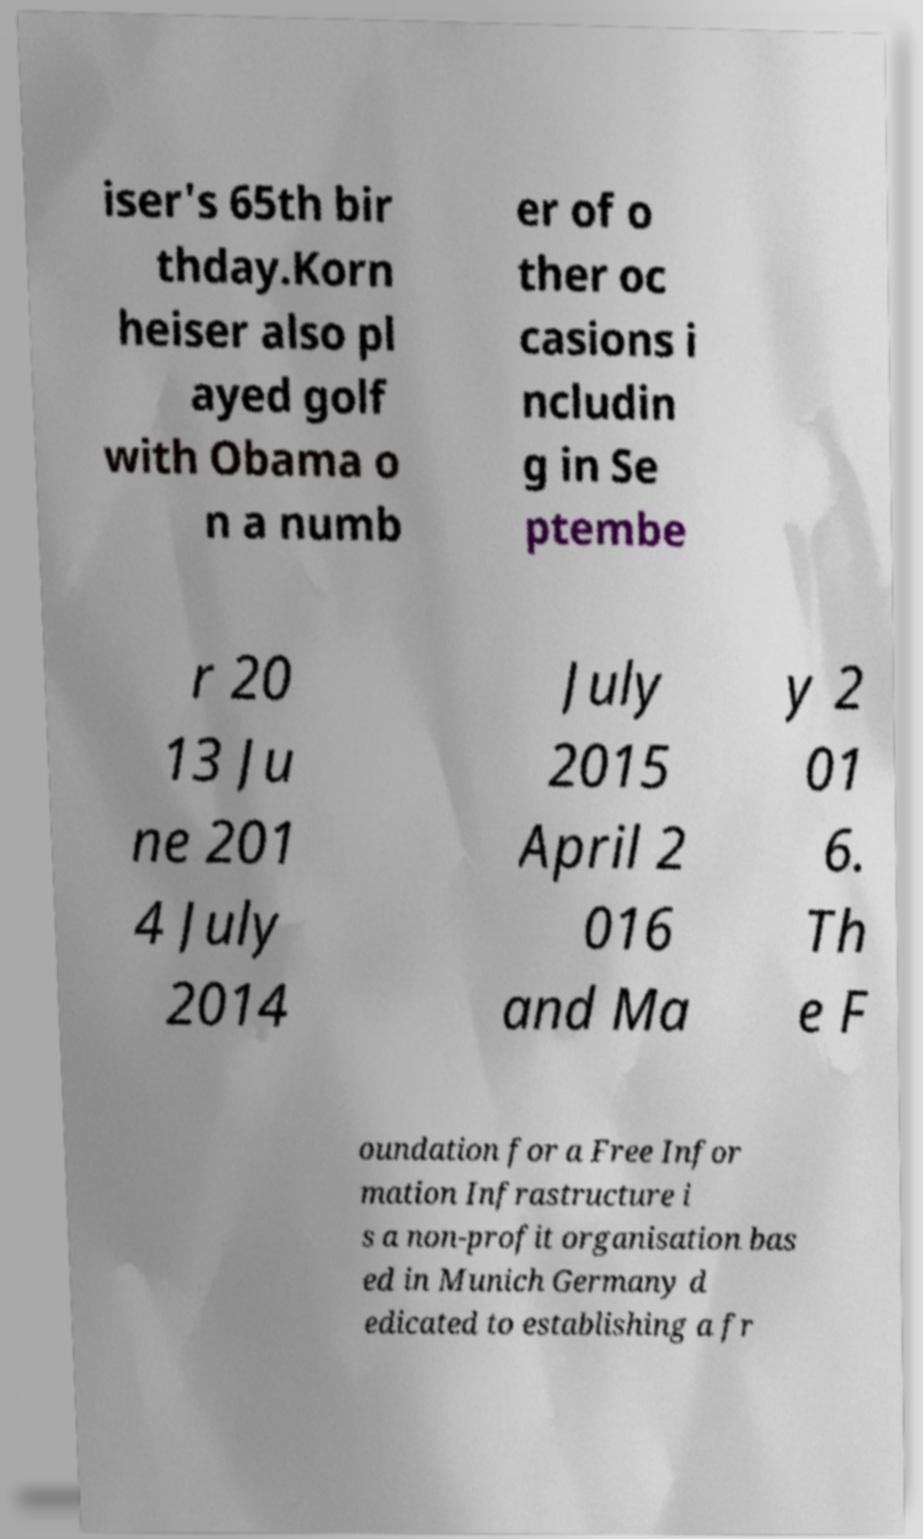I need the written content from this picture converted into text. Can you do that? iser's 65th bir thday.Korn heiser also pl ayed golf with Obama o n a numb er of o ther oc casions i ncludin g in Se ptembe r 20 13 Ju ne 201 4 July 2014 July 2015 April 2 016 and Ma y 2 01 6. Th e F oundation for a Free Infor mation Infrastructure i s a non-profit organisation bas ed in Munich Germany d edicated to establishing a fr 